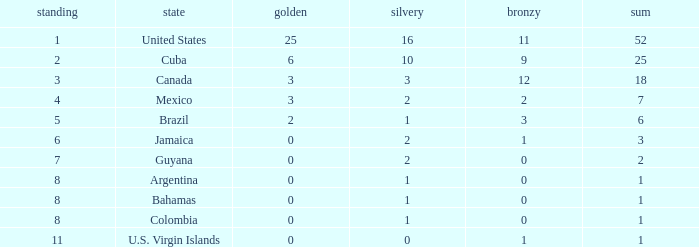What is the fewest number of silver medals a nation who ranked below 8 received? 0.0. 